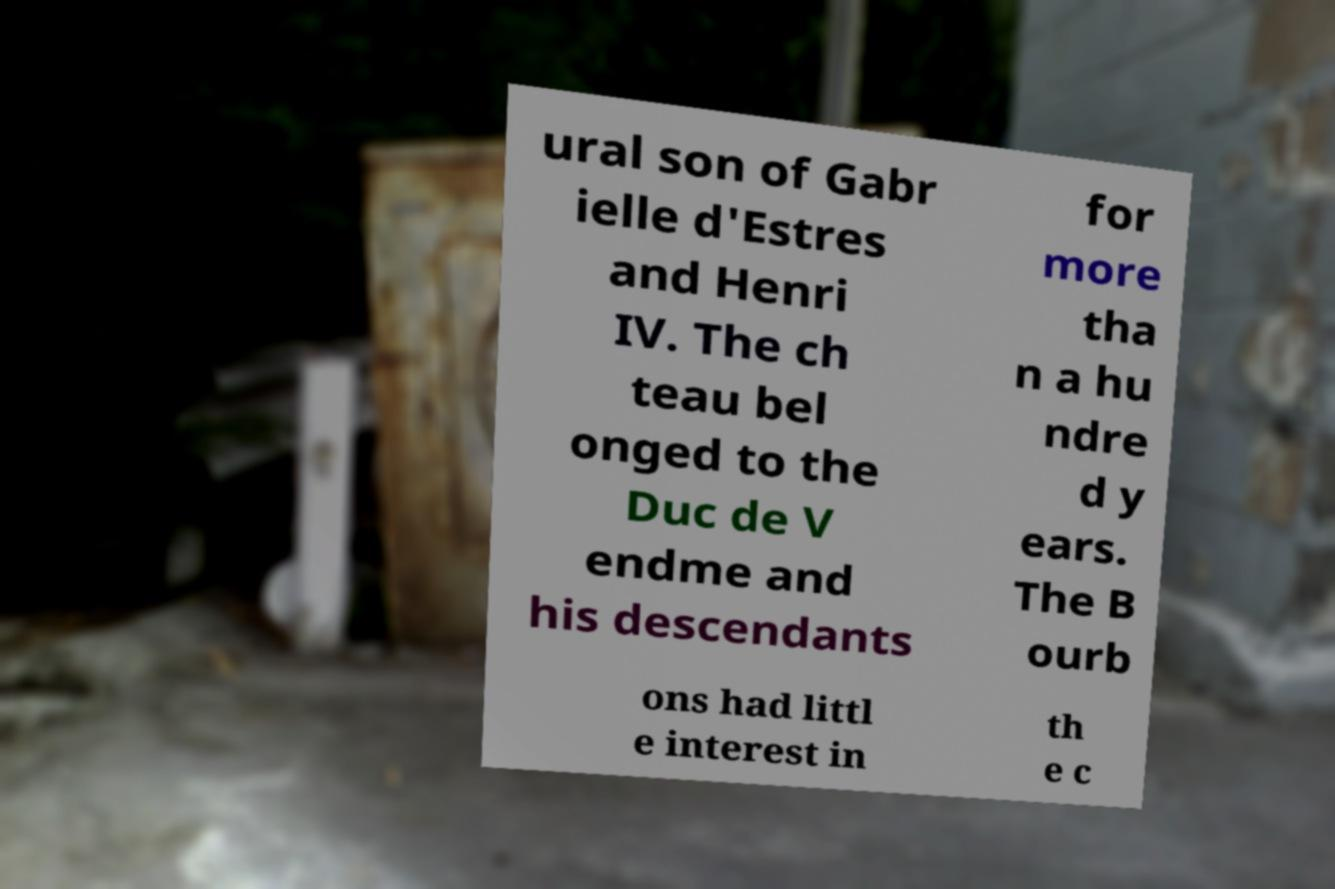There's text embedded in this image that I need extracted. Can you transcribe it verbatim? ural son of Gabr ielle d'Estres and Henri IV. The ch teau bel onged to the Duc de V endme and his descendants for more tha n a hu ndre d y ears. The B ourb ons had littl e interest in th e c 